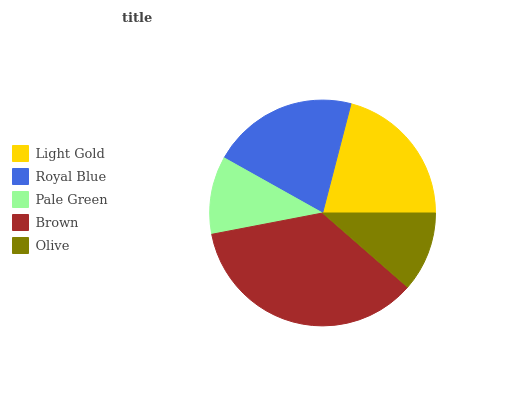Is Pale Green the minimum?
Answer yes or no. Yes. Is Brown the maximum?
Answer yes or no. Yes. Is Royal Blue the minimum?
Answer yes or no. No. Is Royal Blue the maximum?
Answer yes or no. No. Is Light Gold greater than Royal Blue?
Answer yes or no. Yes. Is Royal Blue less than Light Gold?
Answer yes or no. Yes. Is Royal Blue greater than Light Gold?
Answer yes or no. No. Is Light Gold less than Royal Blue?
Answer yes or no. No. Is Royal Blue the high median?
Answer yes or no. Yes. Is Royal Blue the low median?
Answer yes or no. Yes. Is Light Gold the high median?
Answer yes or no. No. Is Pale Green the low median?
Answer yes or no. No. 